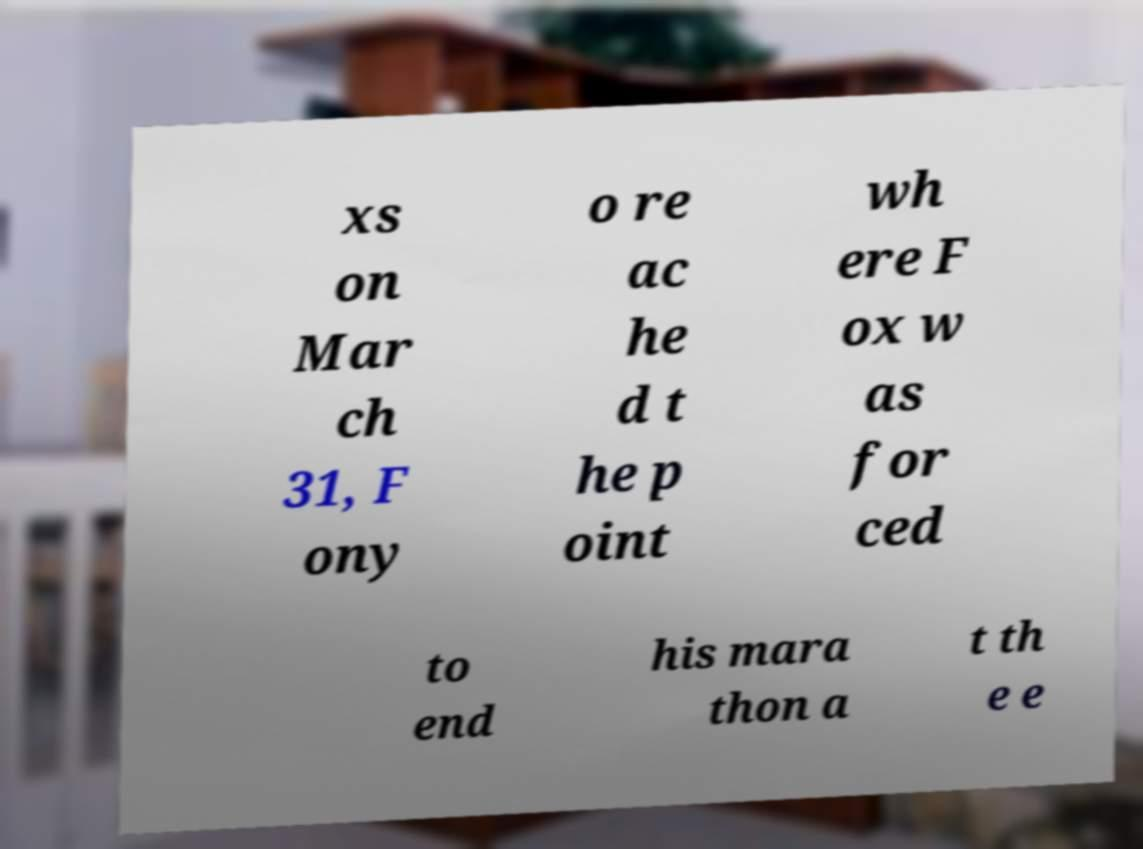There's text embedded in this image that I need extracted. Can you transcribe it verbatim? xs on Mar ch 31, F ony o re ac he d t he p oint wh ere F ox w as for ced to end his mara thon a t th e e 